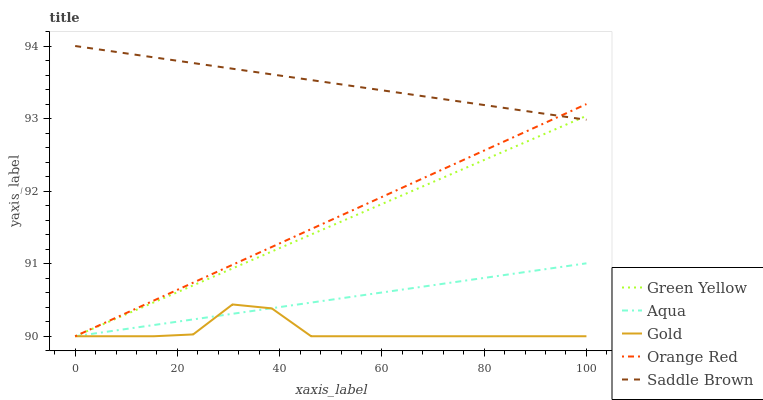Does Gold have the minimum area under the curve?
Answer yes or no. Yes. Does Saddle Brown have the maximum area under the curve?
Answer yes or no. Yes. Does Aqua have the minimum area under the curve?
Answer yes or no. No. Does Aqua have the maximum area under the curve?
Answer yes or no. No. Is Orange Red the smoothest?
Answer yes or no. Yes. Is Gold the roughest?
Answer yes or no. Yes. Is Aqua the smoothest?
Answer yes or no. No. Is Aqua the roughest?
Answer yes or no. No. Does Saddle Brown have the lowest value?
Answer yes or no. No. Does Saddle Brown have the highest value?
Answer yes or no. Yes. Does Aqua have the highest value?
Answer yes or no. No. Is Aqua less than Saddle Brown?
Answer yes or no. Yes. Is Saddle Brown greater than Gold?
Answer yes or no. Yes. Does Gold intersect Green Yellow?
Answer yes or no. Yes. Is Gold less than Green Yellow?
Answer yes or no. No. Is Gold greater than Green Yellow?
Answer yes or no. No. Does Aqua intersect Saddle Brown?
Answer yes or no. No. 